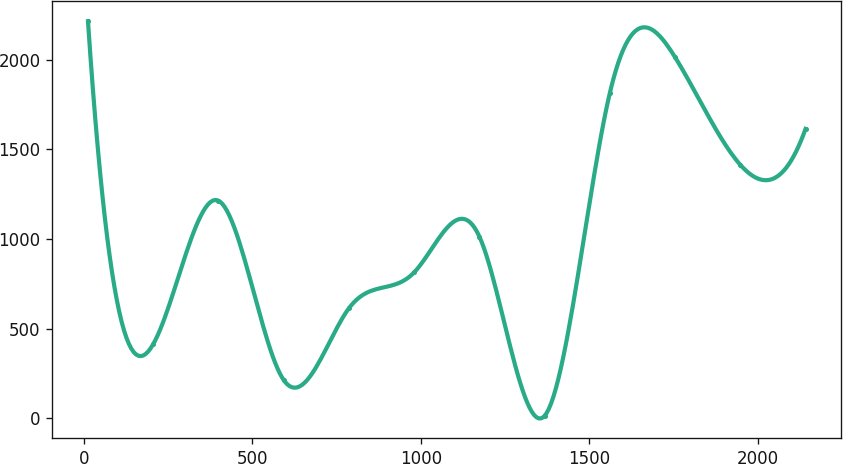Convert chart to OTSL. <chart><loc_0><loc_0><loc_500><loc_500><line_chart><ecel><fcel>Unnamed: 1<nl><fcel>11.8<fcel>2215.11<nl><fcel>205.43<fcel>413.13<nl><fcel>399.06<fcel>1214.01<nl><fcel>592.69<fcel>212.91<nl><fcel>786.32<fcel>613.35<nl><fcel>979.95<fcel>813.57<nl><fcel>1173.58<fcel>1013.79<nl><fcel>1367.21<fcel>12.69<nl><fcel>1560.84<fcel>1814.67<nl><fcel>1754.47<fcel>2014.89<nl><fcel>1948.1<fcel>1414.23<nl><fcel>2141.73<fcel>1614.45<nl></chart> 